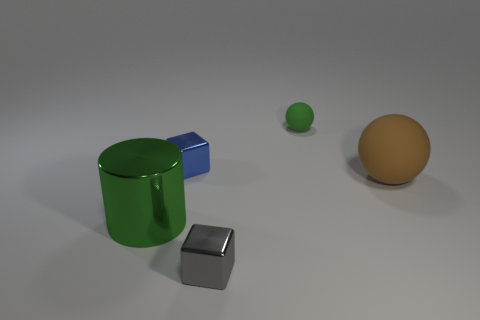Add 3 big brown balls. How many objects exist? 8 Subtract all cylinders. How many objects are left? 4 Subtract all metal objects. Subtract all brown rubber balls. How many objects are left? 1 Add 1 green metal cylinders. How many green metal cylinders are left? 2 Add 3 green objects. How many green objects exist? 5 Subtract 0 blue balls. How many objects are left? 5 